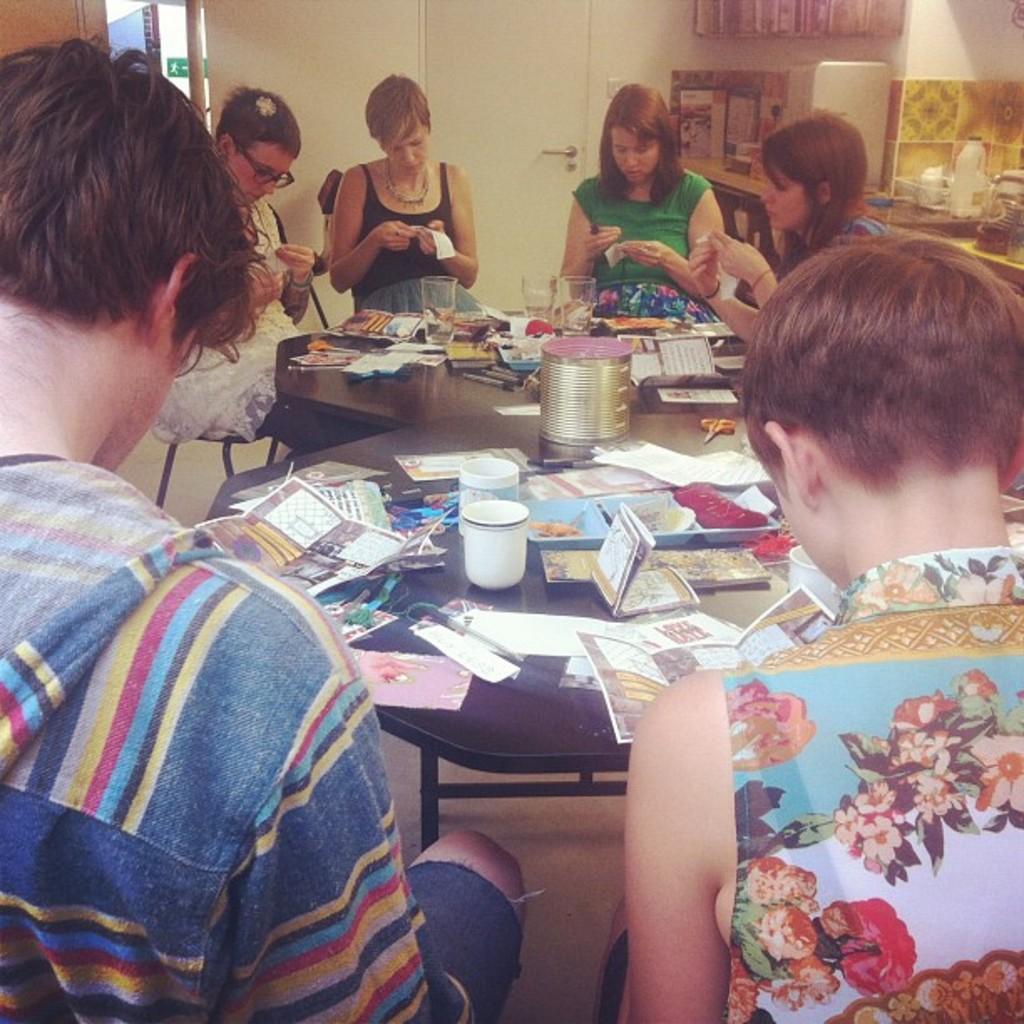Can you describe this image briefly? This picture shows few people seated on the chairs and we see few papers,glasses on the tables and we see a door and women wore a spectacles on her face 